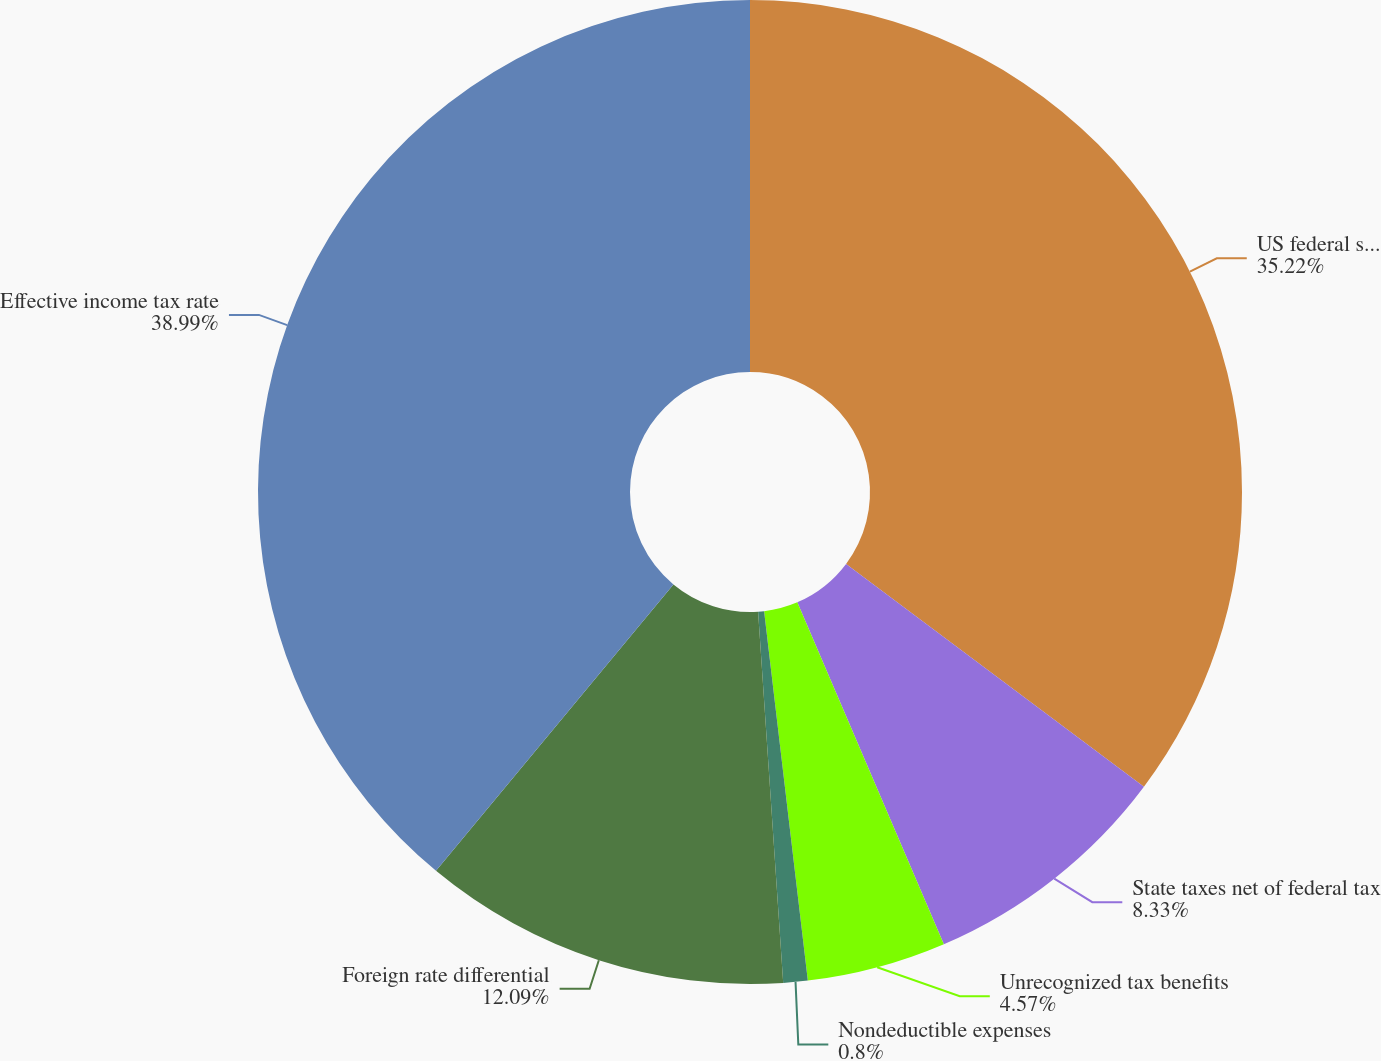<chart> <loc_0><loc_0><loc_500><loc_500><pie_chart><fcel>US federal statutory income<fcel>State taxes net of federal tax<fcel>Unrecognized tax benefits<fcel>Nondeductible expenses<fcel>Foreign rate differential<fcel>Effective income tax rate<nl><fcel>35.22%<fcel>8.33%<fcel>4.57%<fcel>0.8%<fcel>12.09%<fcel>38.98%<nl></chart> 